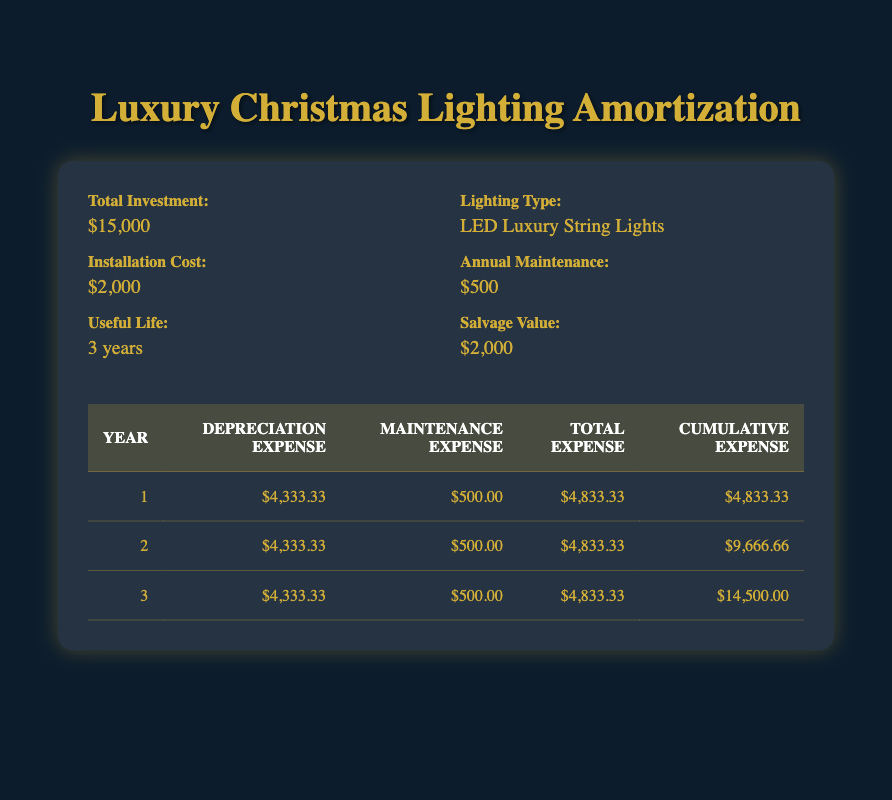What is the total investment for the luxury Christmas lighting? The total investment is explicitly stated in the investment information section of the table as $15,000.
Answer: $15,000 What was the maintenance expense in the second year? The table lists the maintenance expense for year 2 as $500.
Answer: $500 How much was the cumulative expense at the end of year 3? The cumulative expense for year 3 is shown in the table as $14,500. This value represents the total expenses accumulated over the three years.
Answer: $14,500 What is the average depreciation expense per year for the investment? The depreciation expense for each of the three years is $4,333.33. To find the average, we sum the expenses for all three years (4,333.33 * 3) and then divide by 3, resulting in $4,333.33 as the average.
Answer: $4,333.33 Did the maintenance expense increase over the 3 years? The maintenance expense remains constant at $500 each year according to the table, meaning it did not increase.
Answer: No 